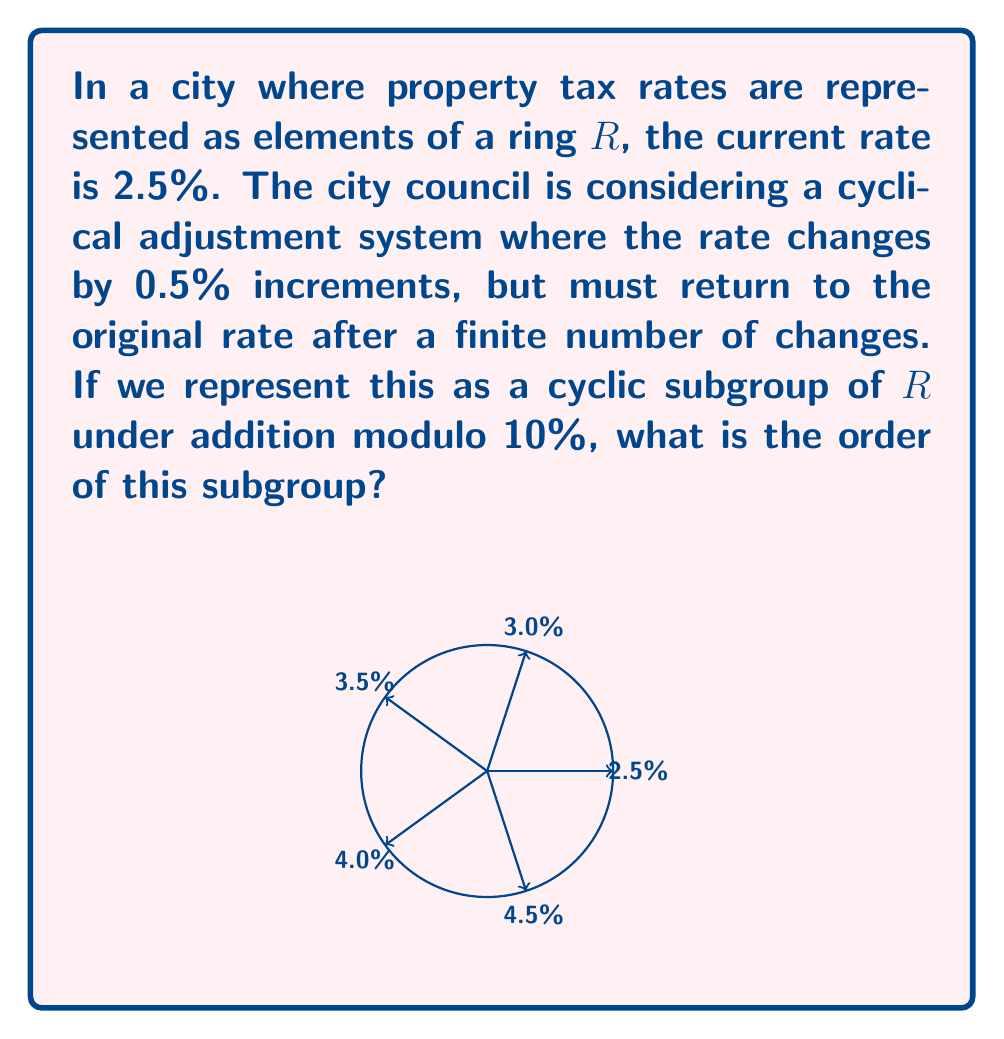Help me with this question. Let's approach this step-by-step:

1) The ring $R$ represents all possible tax rates modulo 10%. 

2) The cyclic subgroup we're considering starts at 2.5% and increases by 0.5% increments.

3) Let's list out the elements of this subgroup:
   $2.5\% \rightarrow 3.0\% \rightarrow 3.5\% \rightarrow 4.0\% \rightarrow 4.5\% \rightarrow 5.0\%$

4) The next element would be $5.5\%$, but we need to consider this modulo 10%:
   $5.5\% \equiv -4.5\% \pmod{10\%}$

5) In the ring $R$, $-4.5\%$ is equivalent to $5.5\%$. The sequence continues:
   $5.5\% \rightarrow 6.0\% \rightarrow 6.5\% \rightarrow 7.0\% \rightarrow 7.5\%$

6) The next element would be $8.0\%$, which is equivalent to $-2.0\%$ in $R$.

7) Continuing: $-2.0\% \rightarrow -1.5\% \rightarrow -1.0\% \rightarrow -0.5\% \rightarrow 0\%$

8) The next element after $0\%$ is $0.5\%$, then $1.0\%$, $1.5\%$, $2.0\%$, and finally back to $2.5\%$.

9) We've listed all unique elements before returning to $2.5\%$. There are 20 elements in total.

Therefore, the order of this cyclic subgroup is 20.
Answer: 20 